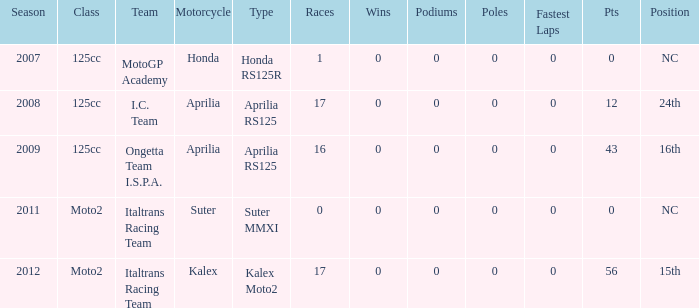What's Italtrans Racing Team's, with 0 pts, class? Moto2. 